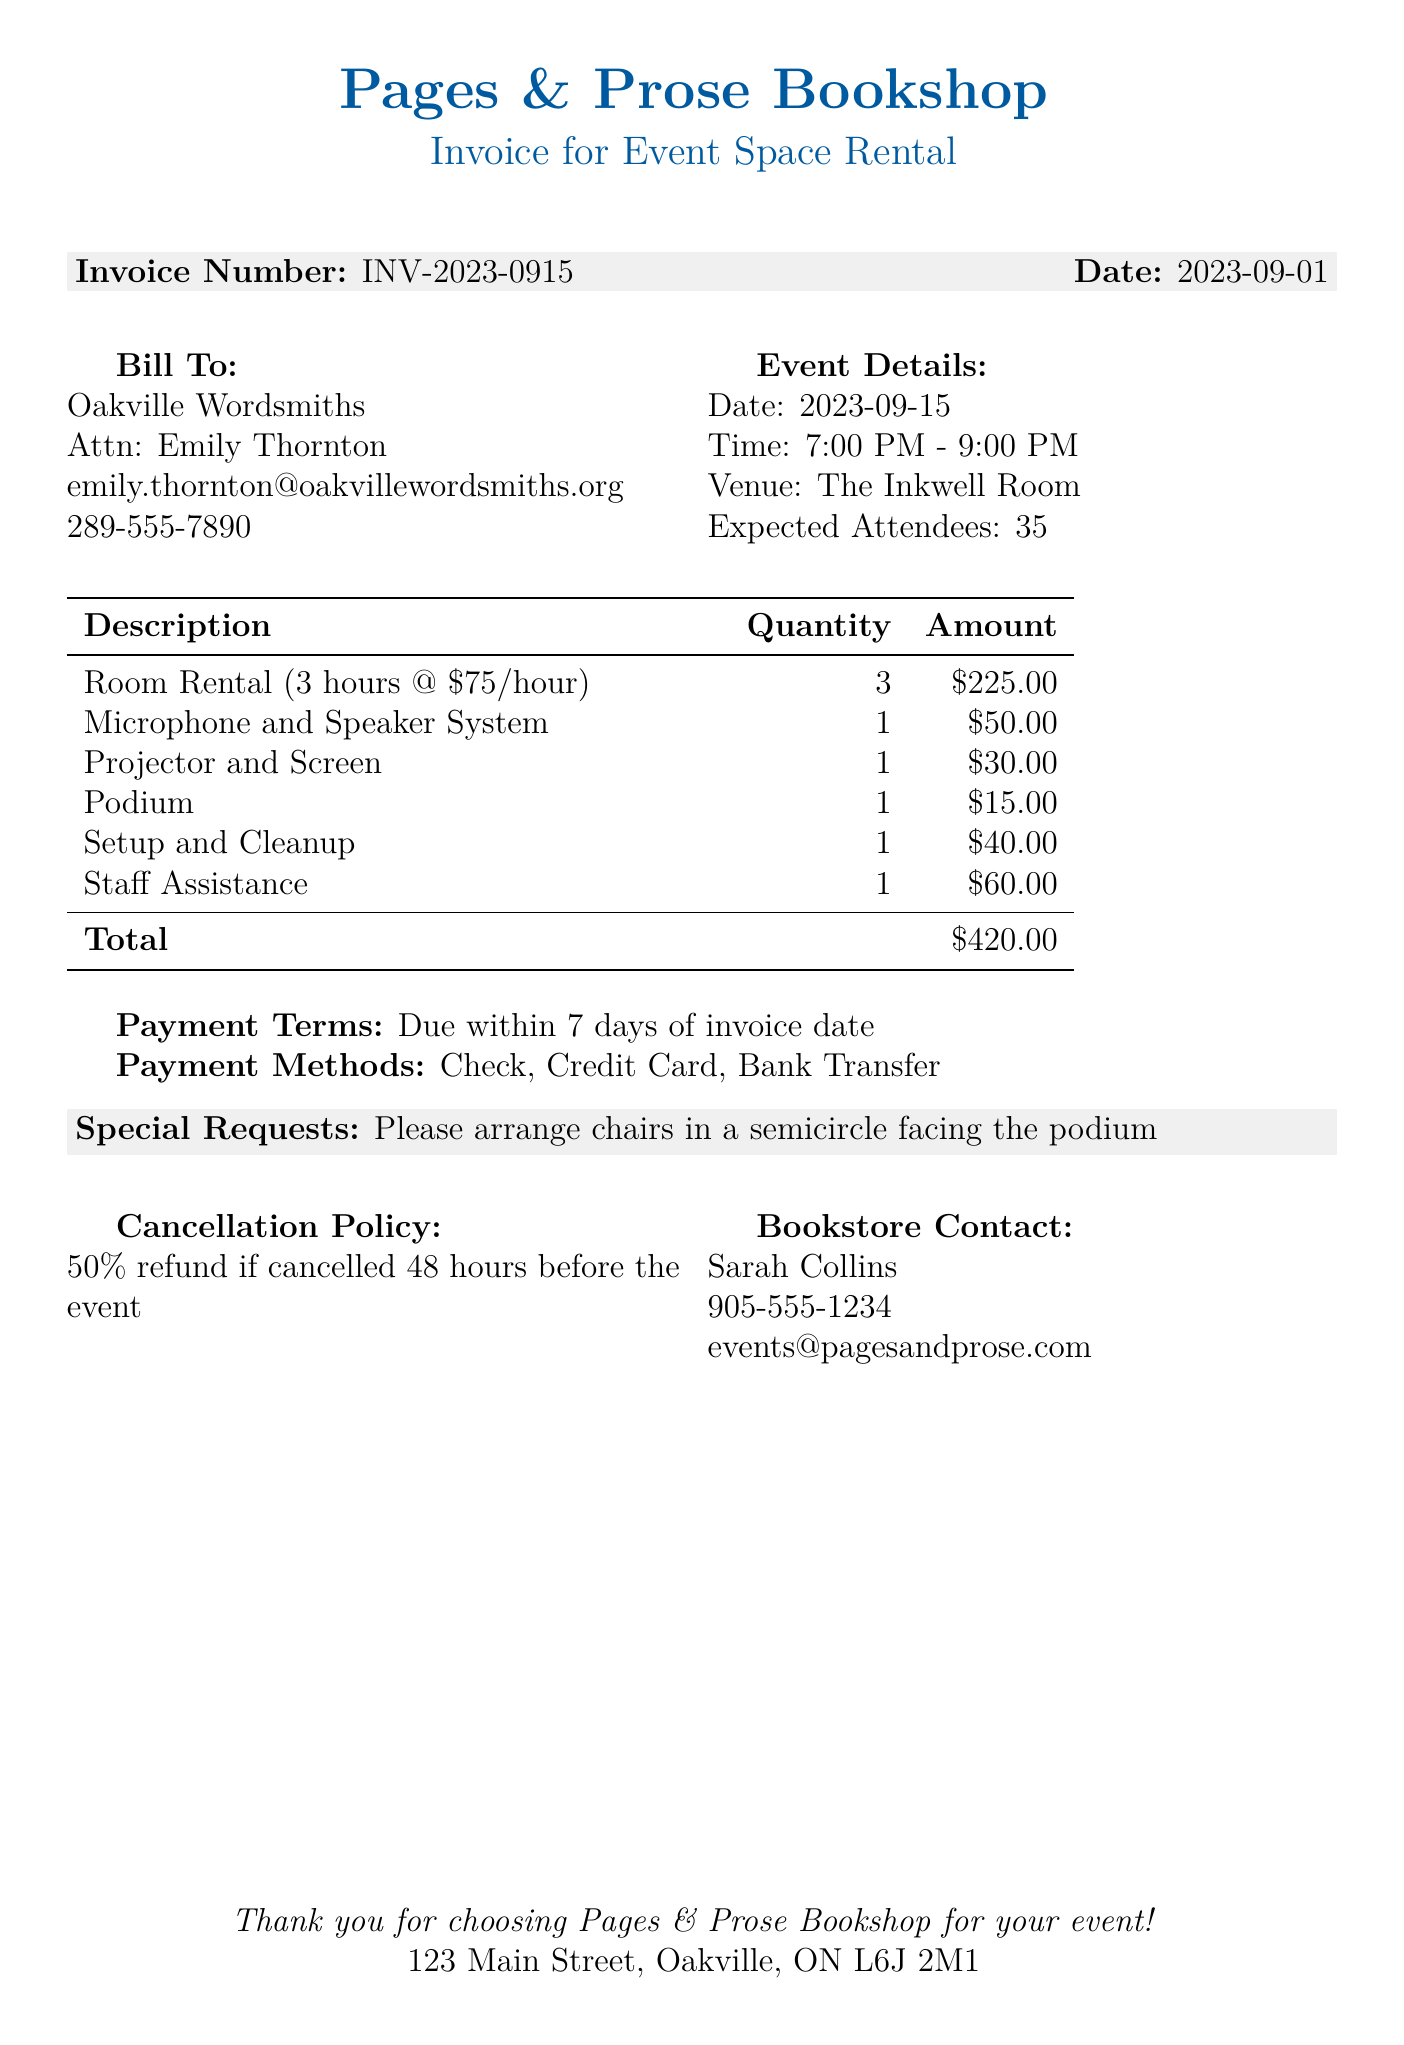What is the bookstore's name? The bookstore's name is provided at the top of the document.
Answer: Pages & Prose Bookshop What event is being hosted? The event description specifies the type of event being held.
Answer: Monthly poetry reading featuring local poets What is the hourly rate for the room rental? The hourly rate is listed in the breakdown of the rental costs.
Answer: 75 How many expected attendees are there? The expected number of attendees is mentioned in the event details section.
Answer: 35 What is the cancellation policy? The document outlines the terms regarding cancellations clearly.
Answer: 50% refund if cancelled 48 hours before the event What is the total amount due for this rental? The total due is summarized in the table of costs at the end.
Answer: $420.00 What equipment fees are charged for the microphone and speaker system? The specific fee for this piece of equipment is detailed in the invoice.
Answer: $50.00 What additional service has a fee of 60? The breakdown lists additional services along with their respective fees; this is one of them.
Answer: Staff Assistance Who is the contact person for the writers' group? The document states the contact person's name in the billing section.
Answer: Emily Thornton What are the accepted payment methods? The document specifically lists the types of payments that are acceptable.
Answer: Check, Credit Card, Bank Transfer 